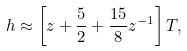Convert formula to latex. <formula><loc_0><loc_0><loc_500><loc_500>h \approx \left [ z + \frac { 5 } { 2 } + \frac { 1 5 } { 8 } z ^ { - 1 } \right ] T ,</formula> 